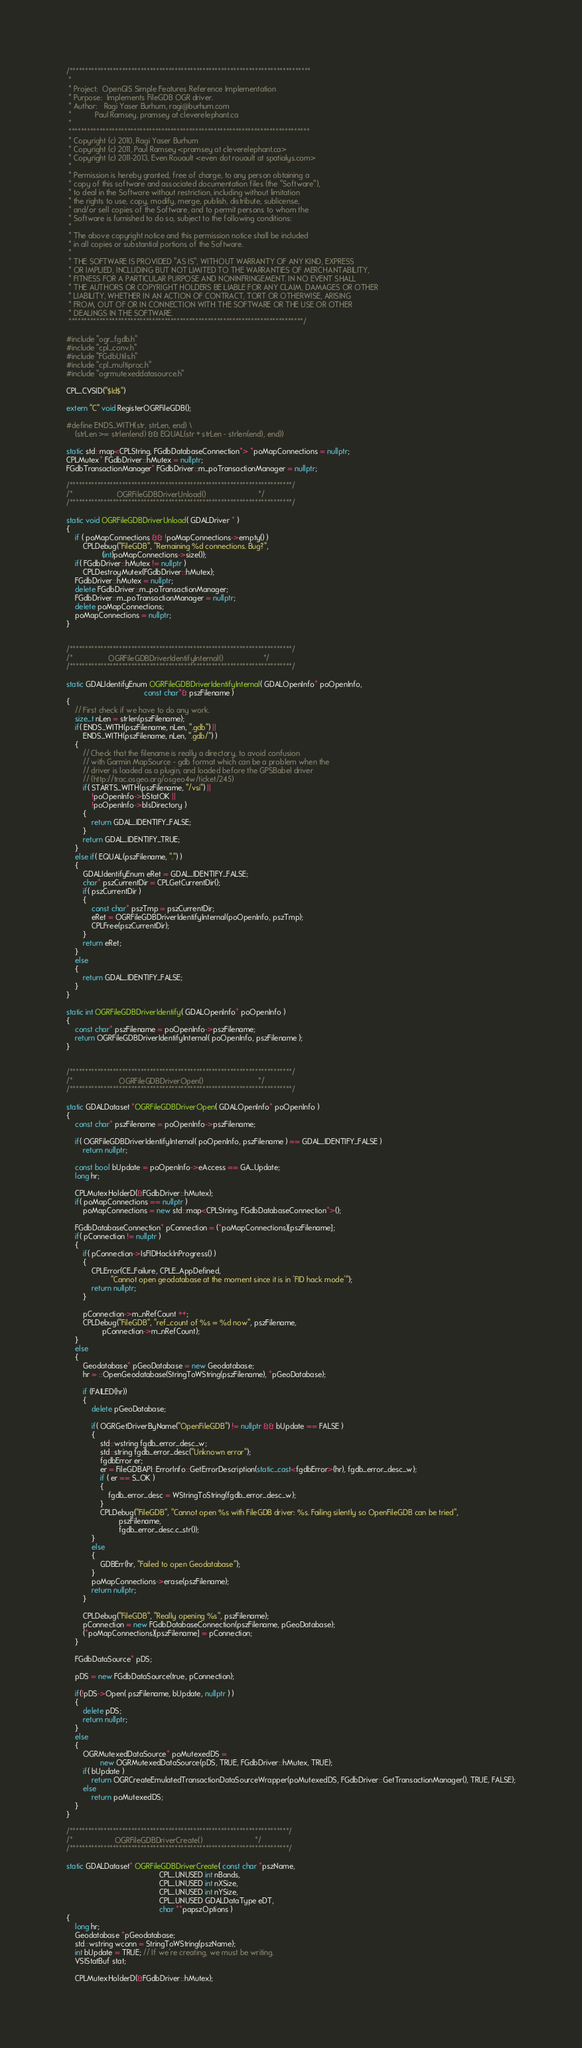<code> <loc_0><loc_0><loc_500><loc_500><_C++_>/******************************************************************************
 *
 * Project:  OpenGIS Simple Features Reference Implementation
 * Purpose:  Implements FileGDB OGR driver.
 * Author:   Ragi Yaser Burhum, ragi@burhum.com
 *           Paul Ramsey, pramsey at cleverelephant.ca
 *
 ******************************************************************************
 * Copyright (c) 2010, Ragi Yaser Burhum
 * Copyright (c) 2011, Paul Ramsey <pramsey at cleverelephant.ca>
 * Copyright (c) 2011-2013, Even Rouault <even dot rouault at spatialys.com>
 *
 * Permission is hereby granted, free of charge, to any person obtaining a
 * copy of this software and associated documentation files (the "Software"),
 * to deal in the Software without restriction, including without limitation
 * the rights to use, copy, modify, merge, publish, distribute, sublicense,
 * and/or sell copies of the Software, and to permit persons to whom the
 * Software is furnished to do so, subject to the following conditions:
 *
 * The above copyright notice and this permission notice shall be included
 * in all copies or substantial portions of the Software.
 *
 * THE SOFTWARE IS PROVIDED "AS IS", WITHOUT WARRANTY OF ANY KIND, EXPRESS
 * OR IMPLIED, INCLUDING BUT NOT LIMITED TO THE WARRANTIES OF MERCHANTABILITY,
 * FITNESS FOR A PARTICULAR PURPOSE AND NONINFRINGEMENT. IN NO EVENT SHALL
 * THE AUTHORS OR COPYRIGHT HOLDERS BE LIABLE FOR ANY CLAIM, DAMAGES OR OTHER
 * LIABILITY, WHETHER IN AN ACTION OF CONTRACT, TORT OR OTHERWISE, ARISING
 * FROM, OUT OF OR IN CONNECTION WITH THE SOFTWARE OR THE USE OR OTHER
 * DEALINGS IN THE SOFTWARE.
 ****************************************************************************/

#include "ogr_fgdb.h"
#include "cpl_conv.h"
#include "FGdbUtils.h"
#include "cpl_multiproc.h"
#include "ogrmutexeddatasource.h"

CPL_CVSID("$Id$")

extern "C" void RegisterOGRFileGDB();

#define ENDS_WITH(str, strLen, end) \
    (strLen >= strlen(end) && EQUAL(str + strLen - strlen(end), end))

static std::map<CPLString, FGdbDatabaseConnection*> *poMapConnections = nullptr;
CPLMutex* FGdbDriver::hMutex = nullptr;
FGdbTransactionManager* FGdbDriver::m_poTransactionManager = nullptr;

/************************************************************************/
/*                     OGRFileGDBDriverUnload()                         */
/************************************************************************/

static void OGRFileGDBDriverUnload( GDALDriver * )
{
    if ( poMapConnections && !poMapConnections->empty() )
        CPLDebug("FileGDB", "Remaining %d connections. Bug?",
                 (int)poMapConnections->size());
    if( FGdbDriver::hMutex != nullptr )
        CPLDestroyMutex(FGdbDriver::hMutex);
    FGdbDriver::hMutex = nullptr;
    delete FGdbDriver::m_poTransactionManager;
    FGdbDriver::m_poTransactionManager = nullptr;
    delete poMapConnections;
    poMapConnections = nullptr;
}


/************************************************************************/
/*                 OGRFileGDBDriverIdentifyInternal()                   */
/************************************************************************/

static GDALIdentifyEnum OGRFileGDBDriverIdentifyInternal( GDALOpenInfo* poOpenInfo,
                                     const char*& pszFilename )
{
    // First check if we have to do any work.
    size_t nLen = strlen(pszFilename);
    if( ENDS_WITH(pszFilename, nLen, ".gdb") ||
        ENDS_WITH(pszFilename, nLen, ".gdb/") )
    {
        // Check that the filename is really a directory, to avoid confusion
        // with Garmin MapSource - gdb format which can be a problem when the
        // driver is loaded as a plugin, and loaded before the GPSBabel driver
        // (http://trac.osgeo.org/osgeo4w/ticket/245)
        if( STARTS_WITH(pszFilename, "/vsi") ||
            !poOpenInfo->bStatOK ||
            !poOpenInfo->bIsDirectory )
        {
            return GDAL_IDENTIFY_FALSE;
        }
        return GDAL_IDENTIFY_TRUE;
    }
    else if( EQUAL(pszFilename, ".") )
    {
        GDALIdentifyEnum eRet = GDAL_IDENTIFY_FALSE;
        char* pszCurrentDir = CPLGetCurrentDir();
        if( pszCurrentDir )
        {
            const char* pszTmp = pszCurrentDir;
            eRet = OGRFileGDBDriverIdentifyInternal(poOpenInfo, pszTmp);
            CPLFree(pszCurrentDir);
        }
        return eRet;
    }
    else
    {
        return GDAL_IDENTIFY_FALSE;
    }
}

static int OGRFileGDBDriverIdentify( GDALOpenInfo* poOpenInfo )
{
    const char* pszFilename = poOpenInfo->pszFilename;
    return OGRFileGDBDriverIdentifyInternal( poOpenInfo, pszFilename );
}


/************************************************************************/
/*                      OGRFileGDBDriverOpen()                          */
/************************************************************************/

static GDALDataset *OGRFileGDBDriverOpen( GDALOpenInfo* poOpenInfo )
{
    const char* pszFilename = poOpenInfo->pszFilename;

    if( OGRFileGDBDriverIdentifyInternal( poOpenInfo, pszFilename ) == GDAL_IDENTIFY_FALSE )
        return nullptr;

    const bool bUpdate = poOpenInfo->eAccess == GA_Update;
    long hr;

    CPLMutexHolderD(&FGdbDriver::hMutex);
    if( poMapConnections == nullptr )
        poMapConnections = new std::map<CPLString, FGdbDatabaseConnection*>();

    FGdbDatabaseConnection* pConnection = (*poMapConnections)[pszFilename];
    if( pConnection != nullptr )
    {
        if( pConnection->IsFIDHackInProgress() )
        {
            CPLError(CE_Failure, CPLE_AppDefined,
                     "Cannot open geodatabase at the moment since it is in 'FID hack mode'");
            return nullptr;
        }

        pConnection->m_nRefCount ++;
        CPLDebug("FileGDB", "ref_count of %s = %d now", pszFilename,
                 pConnection->m_nRefCount);
    }
    else
    {
        Geodatabase* pGeoDatabase = new Geodatabase;
        hr = ::OpenGeodatabase(StringToWString(pszFilename), *pGeoDatabase);

        if (FAILED(hr))
        {
            delete pGeoDatabase;

            if( OGRGetDriverByName("OpenFileGDB") != nullptr && bUpdate == FALSE )
            {
                std::wstring fgdb_error_desc_w;
                std::string fgdb_error_desc("Unknown error");
                fgdbError er;
                er = FileGDBAPI::ErrorInfo::GetErrorDescription(static_cast<fgdbError>(hr), fgdb_error_desc_w);
                if ( er == S_OK )
                {
                    fgdb_error_desc = WStringToString(fgdb_error_desc_w);
                }
                CPLDebug("FileGDB", "Cannot open %s with FileGDB driver: %s. Failing silently so OpenFileGDB can be tried",
                         pszFilename,
                         fgdb_error_desc.c_str());
            }
            else
            {
                GDBErr(hr, "Failed to open Geodatabase");
            }
            poMapConnections->erase(pszFilename);
            return nullptr;
        }

        CPLDebug("FileGDB", "Really opening %s", pszFilename);
        pConnection = new FGdbDatabaseConnection(pszFilename, pGeoDatabase);
        (*poMapConnections)[pszFilename] = pConnection;
    }

    FGdbDataSource* pDS;

    pDS = new FGdbDataSource(true, pConnection);

    if(!pDS->Open( pszFilename, bUpdate, nullptr ) )
    {
        delete pDS;
        return nullptr;
    }
    else
    {
        OGRMutexedDataSource* poMutexedDS =
                new OGRMutexedDataSource(pDS, TRUE, FGdbDriver::hMutex, TRUE);
        if( bUpdate )
            return OGRCreateEmulatedTransactionDataSourceWrapper(poMutexedDS, FGdbDriver::GetTransactionManager(), TRUE, FALSE);
        else
            return poMutexedDS;
    }
}

/***********************************************************************/
/*                    OGRFileGDBDriverCreate()                         */
/***********************************************************************/

static GDALDataset* OGRFileGDBDriverCreate( const char *pszName,
                                            CPL_UNUSED int nBands,
                                            CPL_UNUSED int nXSize,
                                            CPL_UNUSED int nYSize,
                                            CPL_UNUSED GDALDataType eDT,
                                            char **papszOptions )
{
    long hr;
    Geodatabase *pGeodatabase;
    std::wstring wconn = StringToWString(pszName);
    int bUpdate = TRUE; // If we're creating, we must be writing.
    VSIStatBuf stat;

    CPLMutexHolderD(&FGdbDriver::hMutex);
</code> 